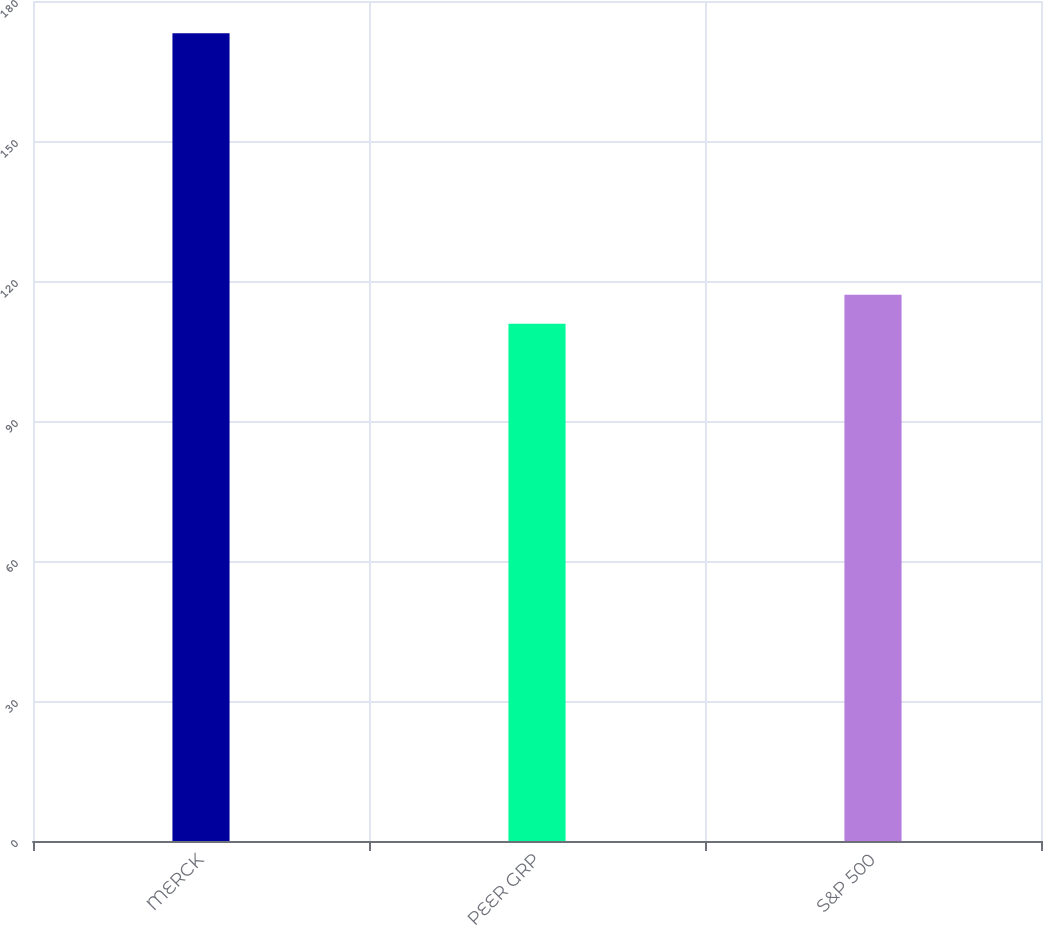Convert chart. <chart><loc_0><loc_0><loc_500><loc_500><bar_chart><fcel>MERCK<fcel>PEER GRP<fcel>S&P 500<nl><fcel>173.1<fcel>110.83<fcel>117.06<nl></chart> 